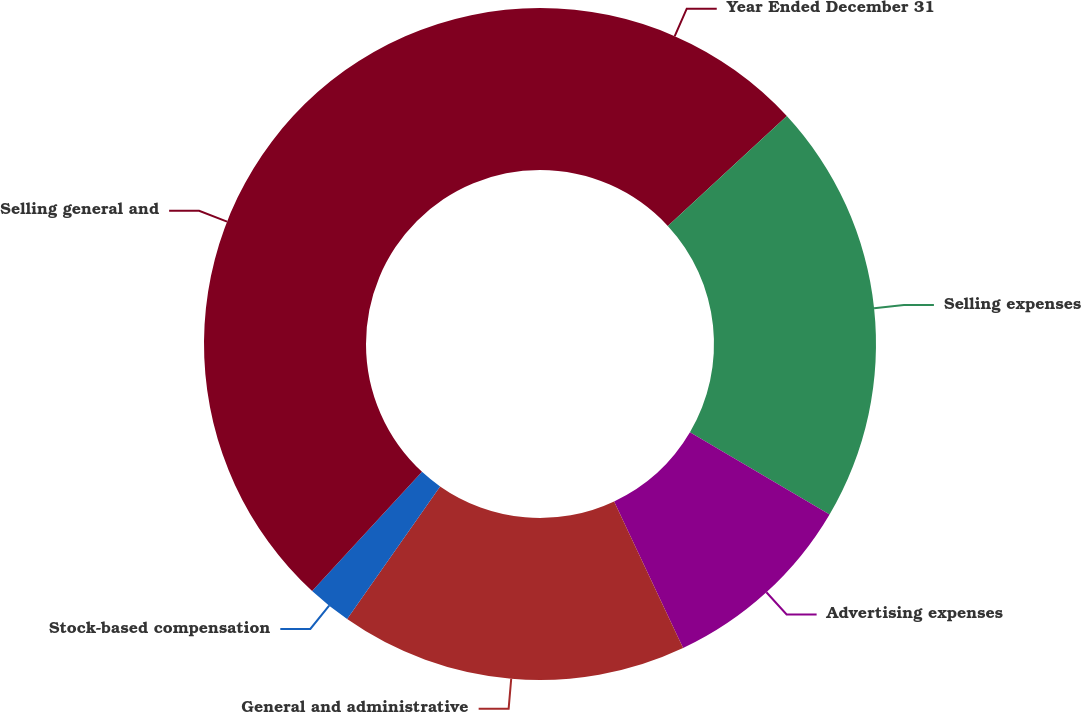<chart> <loc_0><loc_0><loc_500><loc_500><pie_chart><fcel>Year Ended December 31<fcel>Selling expenses<fcel>Advertising expenses<fcel>General and administrative<fcel>Stock-based compensation<fcel>Selling general and<nl><fcel>13.13%<fcel>20.33%<fcel>9.53%<fcel>16.73%<fcel>2.13%<fcel>38.13%<nl></chart> 